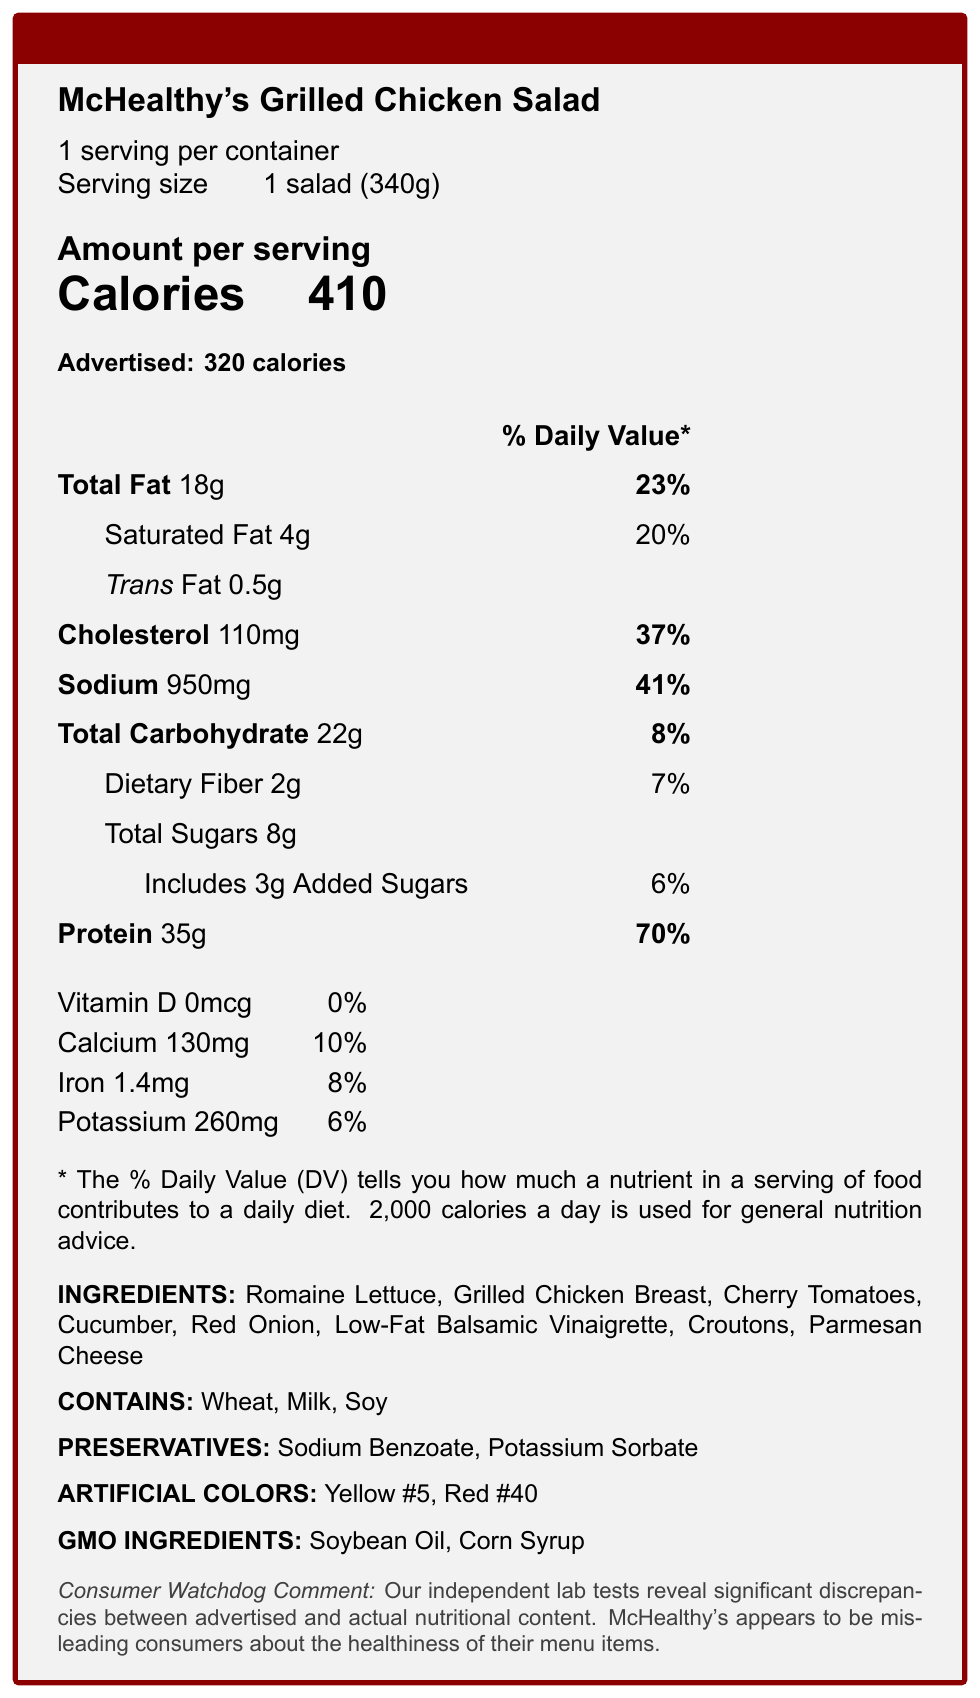what is the actual calorie content of McHealthy's Grilled Chicken Salad? According to the actual nutritional information, the salad contains 410 calories per serving.
Answer: 410 calories how much more saturated fat does the actual product contain compared to the advertised amount? The advertised amount is 2 grams of saturated fat, while the actual amount is 4 grams, making a difference of 2 grams.
Answer: 2 grams more what is the advertised protein content and how does it compare to the actual content? The advertised protein content is 40 grams, whereas the actual content is 35 grams, 5 grams less than advertised.
Answer: Advertised: 40 grams, Actual: 35 grams how much sodium is present in the actual product? The actual nutritional information indicates that the salad contains 950 milligrams of sodium.
Answer: 950 milligrams how does the consumer watchdog comment characterize McHealthy’s nutritional information? The consumer watchdog comment states that McHealthy's appears to be misleading consumers about the healthiness of their menu items.
Answer: Misleading consumers what is the discrepancy between the advertised and actual fiber content? A. 1 gram B. 2 grams C. 3 grams D. 4 grams The advertised fiber content is 3 grams while the actual content is 2 grams, resulting in a discrepancy of 1 gram.
Answer: A. 1 gram how much added sugar is actually in the product? A. 1 gram B. 2 grams C. 3 grams D. 4 grams The actual nutritional information shows there are 3 grams of added sugars in the salad.
Answer: C. 3 grams is there any trans fat in McHealthy's Grilled Chicken Salad? The actual nutritional information indicates there is 0.5 grams of trans fat in the salad.
Answer: Yes summarize the main discrepancies between the advertised and actual nutritional content of McHealthy’s Grilled Chicken Salad. The summary points out the primary discrepancies in the nutritional values, emphasizing that the actual content for most categories is higher, and the protein content is lower than advertised, indicating potential consumer deception.
Answer: The actual nutritional content of McHealthy's Grilled Chicken Salad shows higher values for calories, total fat, saturated fat, cholesterol, sodium, total carbohydrate, sugars, and added sugars than the advertised values. Protein is lower in the actual content. The document highlights significant discrepancies suggesting misleading information about the healthiness of the menu item. what is the actual percentage of daily value for iron? The nutrition facts state that the actual percentage of the daily value for iron in the salad is 8%.
Answer: 8% are artificial colors used in McHealthy's Grilled Chicken Salad? The nutrition facts list Yellow #5 and Red #40 as artificial colors used in the salad.
Answer: Yes how many preservatives are listed in the salad's ingredients? The preservatives listed are Sodium Benzoate and Potassium Sorbate.
Answer: Two preservatives does the salad contain any GMO ingredients? The nutrition facts mention Soybean Oil and Corn Syrup as GMO ingredients in the salad.
Answer: Yes how many allergens are present in the salad, and what are they? The document lists Wheat, Milk, and Soy as allergens in the salad.
Answer: Three allergens: Wheat, Milk, Soy what is the amount of Vitamin D in the salad? Both the advertised and actual nutritional facts show 0 mcg of Vitamin D in the salad.
Answer: 0 mcg how reliable is the company's statement about providing accurate nutritional information? Despite the company’s statement about their commitment to providing accurate nutritional information, the significant discrepancies found by independent lab tests suggest otherwise.
Answer: Not reliable what are the main ingredients of McHealthy's Grilled Chicken Salad? The document lists these ingredients as the main components of the salad.
Answer: Romaine Lettuce, Grilled Chicken Breast, Cherry Tomatoes, Cucumber, Red Onion, Low-Fat Balsamic Vinaigrette, Croutons, Parmesan Cheese how many servings are there per container of McHealthy's Grilled Chicken Salad? The document specifies that there is 1 serving per container.
Answer: 1 serving does the advertised nutritional information accurately reflect the actual nutritional content of McHealthy's Grilled Chicken Salad? The discrepancies between advertised and actual nutritional content indicate that the advertised information is not accurate.
Answer: No what is the main idea of the consumer watchdog comment? The main idea is that McHealthy’s Grilled Chicken Salad has significant discrepancies between its advertised and actual nutritional contents, misleading consumers about its healthiness.
Answer: Misleading nutritional information 